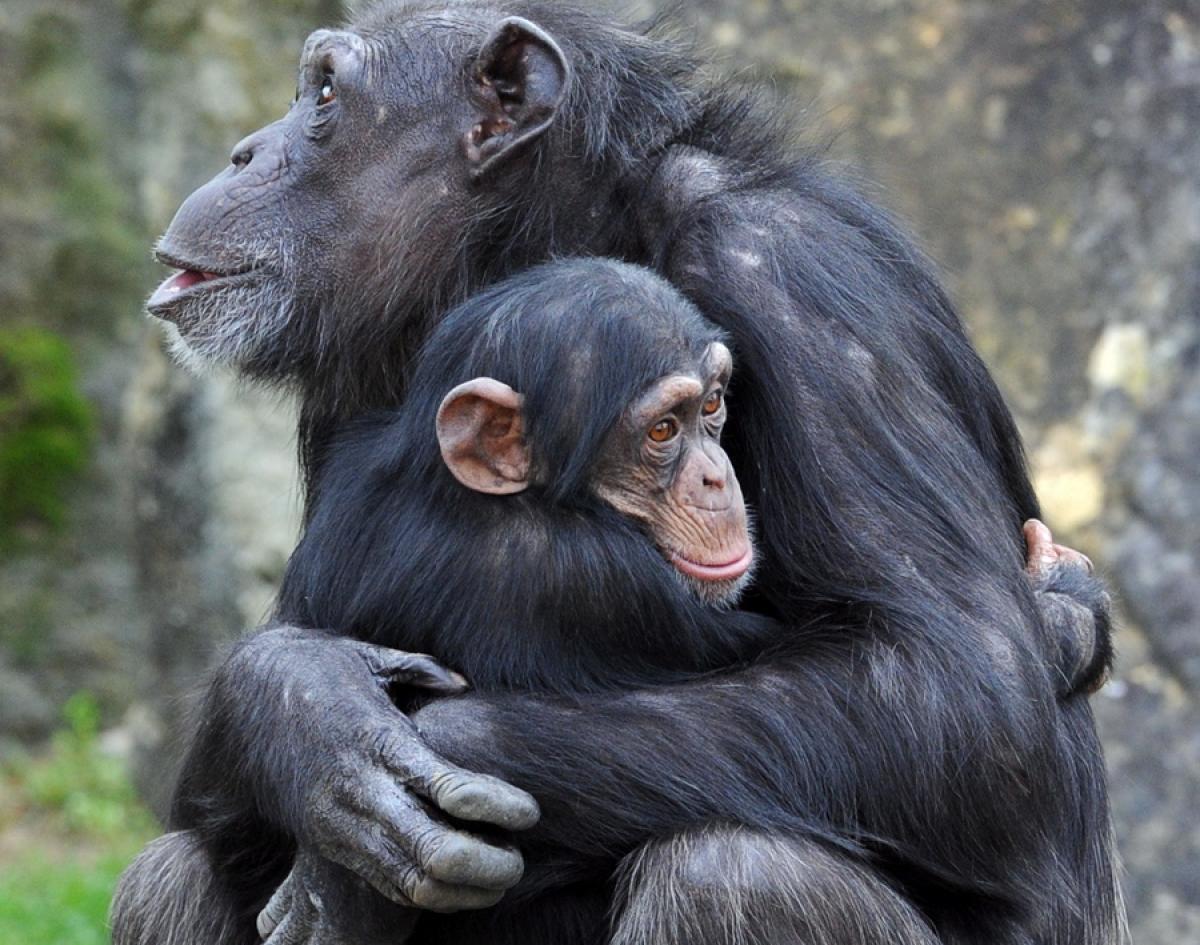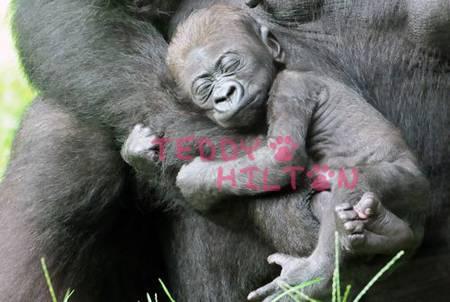The first image is the image on the left, the second image is the image on the right. For the images shown, is this caption "Each image shows a larger animal hugging a smaller one." true? Answer yes or no. Yes. 